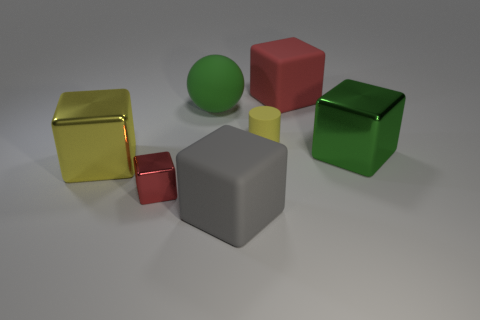Subtract all yellow blocks. How many blocks are left? 4 Subtract all small cubes. How many cubes are left? 4 Subtract all cyan blocks. Subtract all cyan balls. How many blocks are left? 5 Add 2 red matte spheres. How many objects exist? 9 Subtract all cubes. How many objects are left? 2 Add 4 blocks. How many blocks exist? 9 Subtract 0 purple balls. How many objects are left? 7 Subtract all big gray matte blocks. Subtract all green objects. How many objects are left? 4 Add 3 balls. How many balls are left? 4 